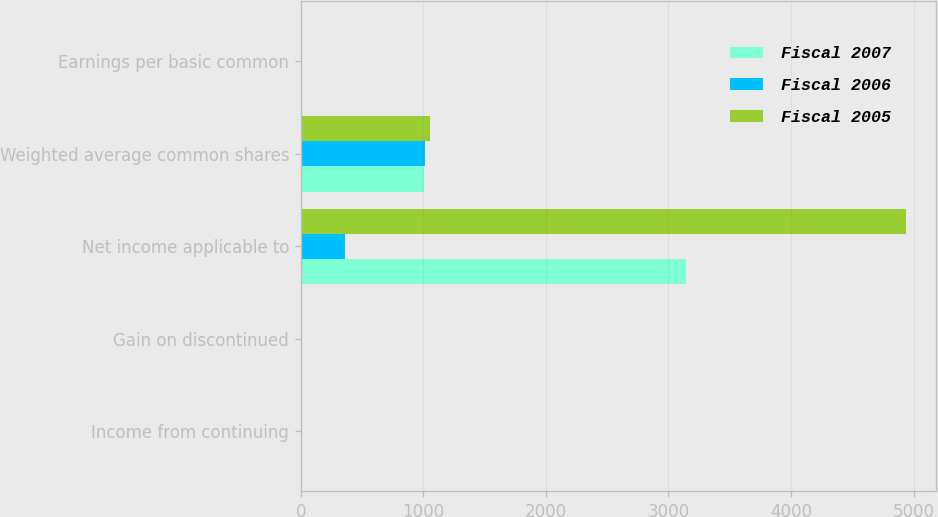Convert chart to OTSL. <chart><loc_0><loc_0><loc_500><loc_500><stacked_bar_chart><ecel><fcel>Income from continuing<fcel>Gain on discontinued<fcel>Net income applicable to<fcel>Weighted average common shares<fcel>Earnings per basic common<nl><fcel>Fiscal 2007<fcel>2.49<fcel>0.64<fcel>3141<fcel>1002<fcel>3.13<nl><fcel>Fiscal 2006<fcel>6.25<fcel>1.13<fcel>358<fcel>1010<fcel>7.38<nl><fcel>Fiscal 2005<fcel>4.32<fcel>0.33<fcel>4939<fcel>1050<fcel>4.7<nl></chart> 